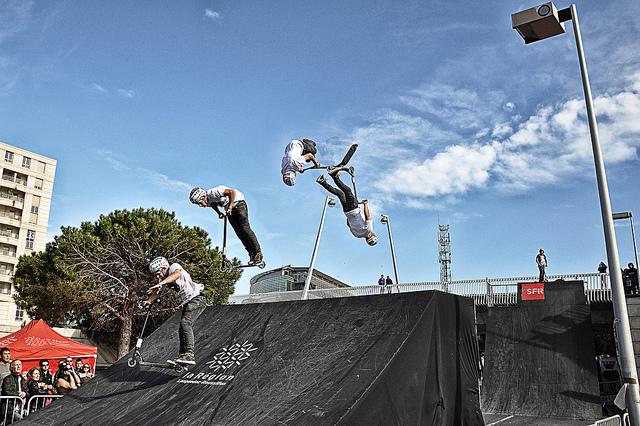Is the skater wearing a helmet?
Give a very brief answer. Yes. Are people watching the skater?
Give a very brief answer. Yes. How many skater's are shown?
Be succinct. 4. 